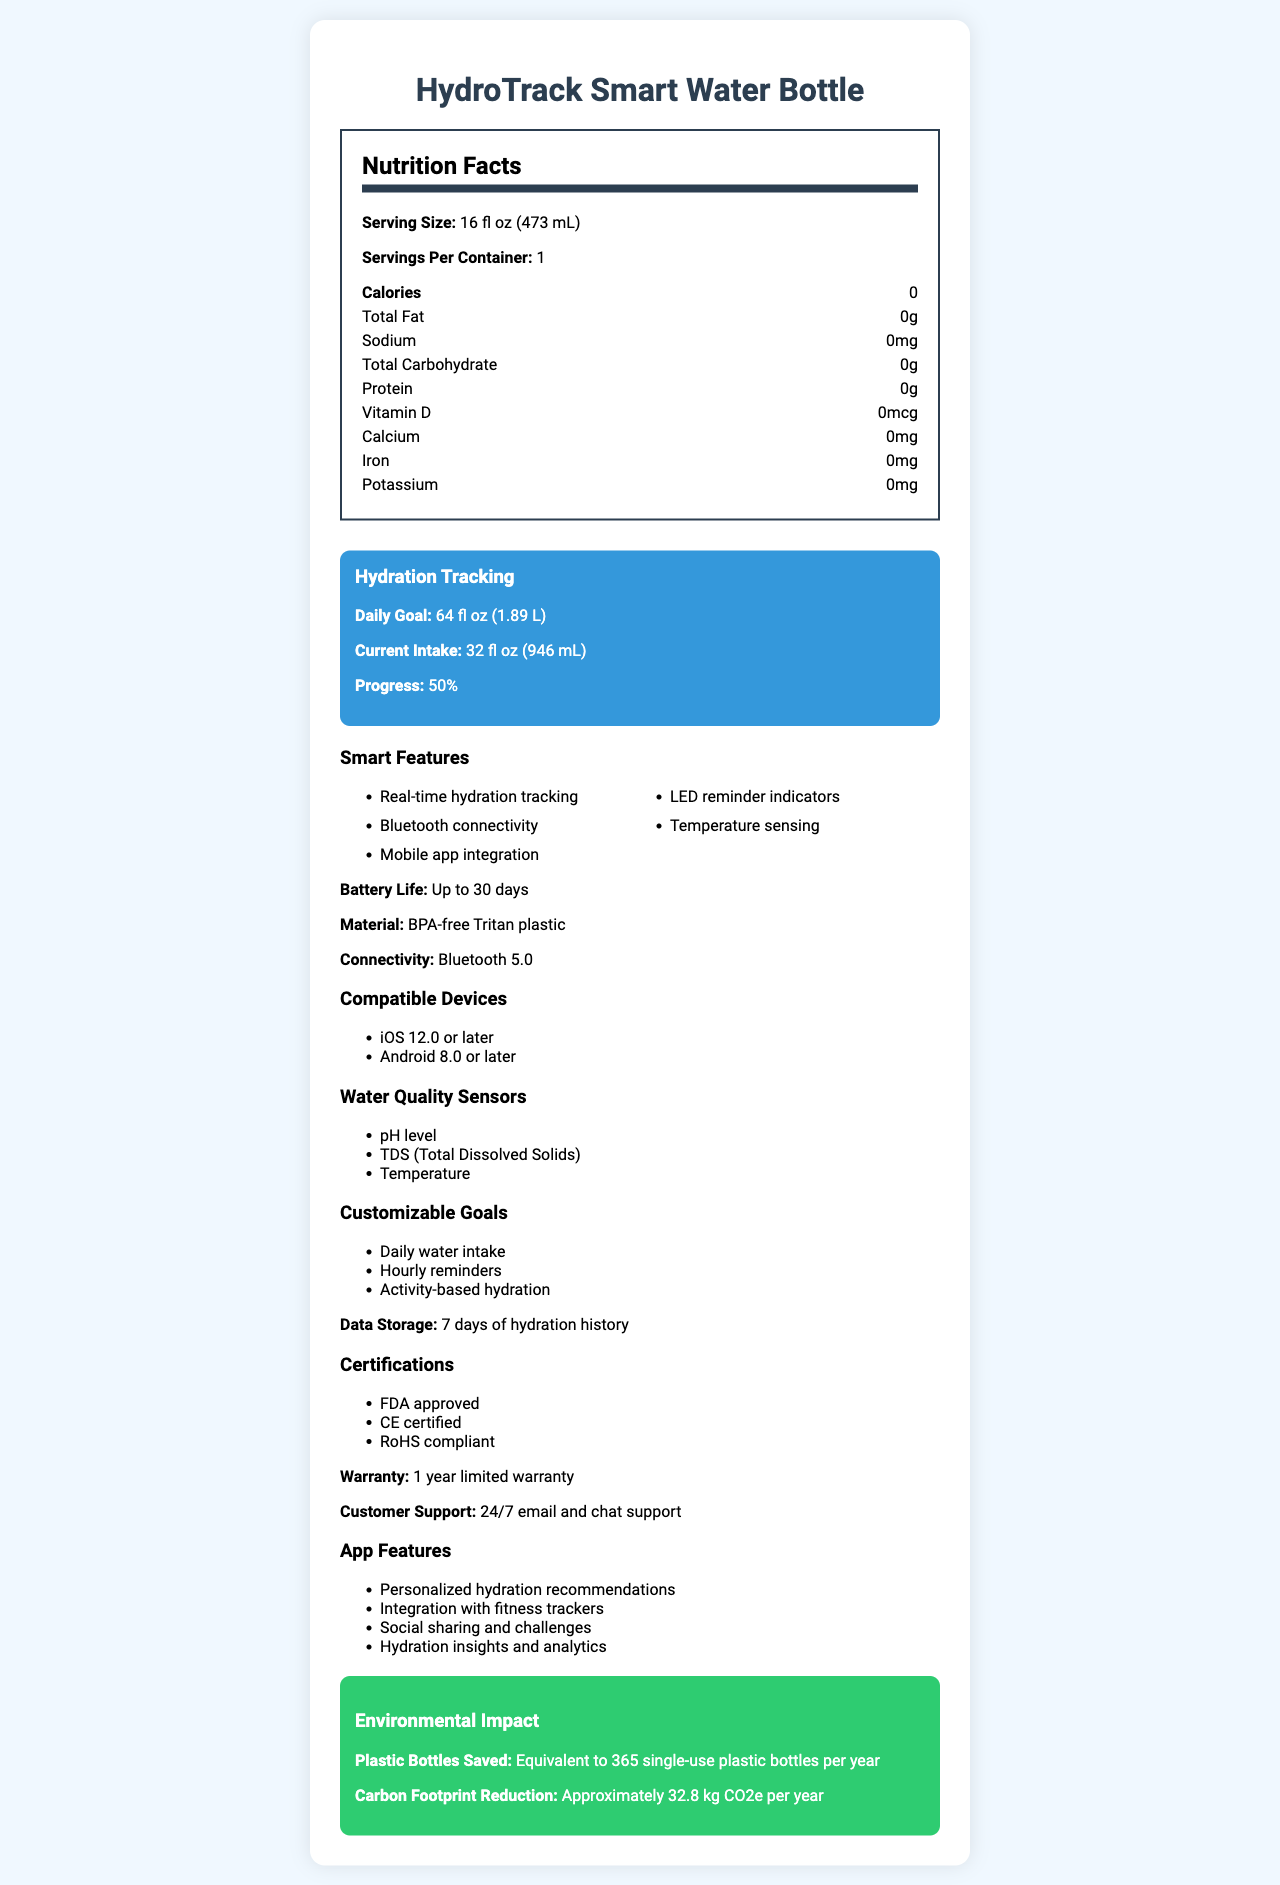what is the serving size of the HydroTrack Smart Water Bottle? The serving size is specified in the nutrition facts section of the document as "16 fl oz (473 mL)".
Answer: 16 fl oz (473 mL) how many servings per container does the HydroTrack Smart Water Bottle have? The document states "Servings Per Container: 1" in the nutrition facts section.
Answer: 1 what is the daily hydration goal set by the HydroTrack Smart Water Bottle? Under the hydration tracking section, the daily goal is mentioned as "64 fl oz (1.89 L)".
Answer: 64 fl oz (1.89 L) which type of plastic is used in the HydroTrack Smart Water Bottle? The material of the bottle is listed in the document as "BPA-free Tritan plastic".
Answer: BPA-free Tritan plastic what is the warranty period for the HydroTrack Smart Water Bottle? The document states that the product comes with a "1 year limited warranty".
Answer: 1 year limited warranty what are the smart features available in the HydroTrack Smart Water Bottle? A. LED reminder indicators B. Mobile app integration C. Real-time hydration tracking D. Temperature sensing E. All of the above All these features (LED reminder indicators, Mobile app integration, Real-time hydration tracking, and Temperature sensing) are listed under the smart features section of the document.
Answer: E. All of the above which certifications does the HydroTrack Smart Water Bottle have? I. FDA approved II. CE certified III. RoHS compliant IV. Energy Star The document lists the HydroTrack certifications as FDA approved, CE certified, and RoHS compliant. Energy Star is not mentioned.
Answer: I, II, III is the HydroTrack Smart Water Bottle compatible with Android 7.0? The document states it is compatible with "iOS 12.0 or later" and "Android 8.0 or later," meaning it does not support Android 7.0.
Answer: No describe the main functionalities and features of the HydroTrack Smart Water Bottle. This covers the main functionalities and features as outlined in different sections of the document, summarizing the hydration tracking, connectivity, smart features, materials, certifications, environmental impact, and support offered.
Answer: The HydroTrack Smart Water Bottle is designed to track hydration levels with features including real-time hydration tracking, Bluetooth connectivity, and mobile app integration. It has LED reminder indicators and temperature sensing to enhance user experience. It stores up to 7 days of hydration history, integrates with fitness trackers, and provides personalized hydration recommendations. The bottle is made of BPA-free Tritan plastic, has a battery life of up to 30 days, and is compatible with iOS and Android devices. It also includes pH level, TDS, and temperature sensors for water quality monitoring and offers a 1-year limited warranty with 24/7 customer support. Finally, it has multiple certifications and demonstrates significant environmental impact by saving plastic bottles and reducing the carbon footprint. how many single-use plastic bottles per year does the HydroTrack Smart Water Bottle save? The environmental impact section states that using the HydroTrack Smart Water Bottle saves the equivalent of 365 single-use plastic bottles per year.
Answer: 365 what sensors are included for water quality monitoring in the HydroTrack Smart Water Bottle? The document lists these sensors under the water quality sensors section.
Answer: pH level, TDS (Total Dissolved Solids), Temperature how long can the HydroTrack Smart Water Bottle's battery last on a single charge? The battery life is detailed as "Up to 30 days" in the document.
Answer: Up to 30 days which operating systems are compatible with the HydroTrack Smart Water Bottle? The compatible devices section lists these operating systems.
Answer: iOS 12.0 or later, Android 8.0 or later what app features are provided to enhance the user experience with the HydroTrack Smart Water Bottle? These features are listed under the app features section of the document.
Answer: Personalized hydration recommendations, Integration with fitness trackers, Social sharing and challenges, Hydration insights and analytics can you determine the cost of the HydroTrack Smart Water Bottle from the visual document? The document does not provide any information regarding the price or cost of the HydroTrack Smart Water Bottle.
Answer: Not enough information 